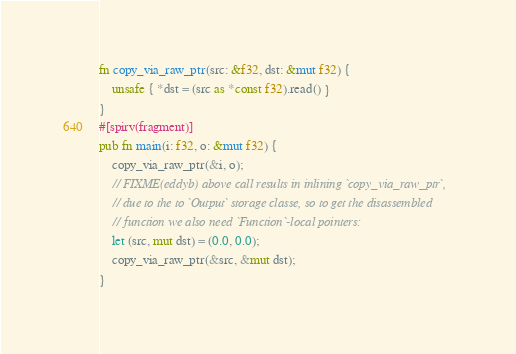Convert code to text. <code><loc_0><loc_0><loc_500><loc_500><_Rust_>
fn copy_via_raw_ptr(src: &f32, dst: &mut f32) {
    unsafe { *dst = (src as *const f32).read() }
}
#[spirv(fragment)]
pub fn main(i: f32, o: &mut f32) {
    copy_via_raw_ptr(&i, o);
    // FIXME(eddyb) above call results in inlining `copy_via_raw_ptr`,
    // due to the to `Output` storage classe, so to get the disassembled
    // function we also need `Function`-local pointers:
    let (src, mut dst) = (0.0, 0.0);
    copy_via_raw_ptr(&src, &mut dst);
}
</code> 